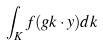Convert formula to latex. <formula><loc_0><loc_0><loc_500><loc_500>\int _ { K } f ( g k \cdot y ) d k</formula> 